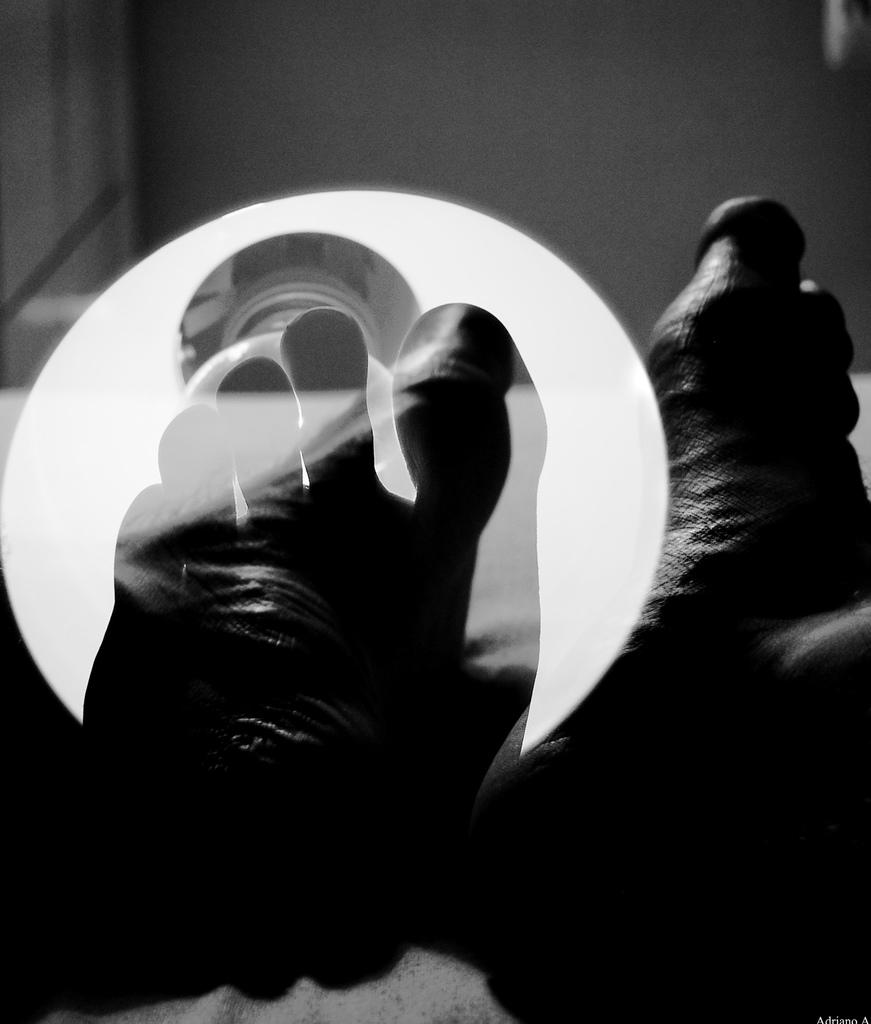What is located in front of the bulb in the image? There is a leg in front of a bulb in the image. Can you describe the other leg in the image? There is another leg on the right side of the image. What is the color scheme of the image? The image is in black and white. What type of milk is being poured from the instrument in the image? There is no milk or instrument present in the image. How much salt is visible on the leg in the image? There is no salt present in the image. 